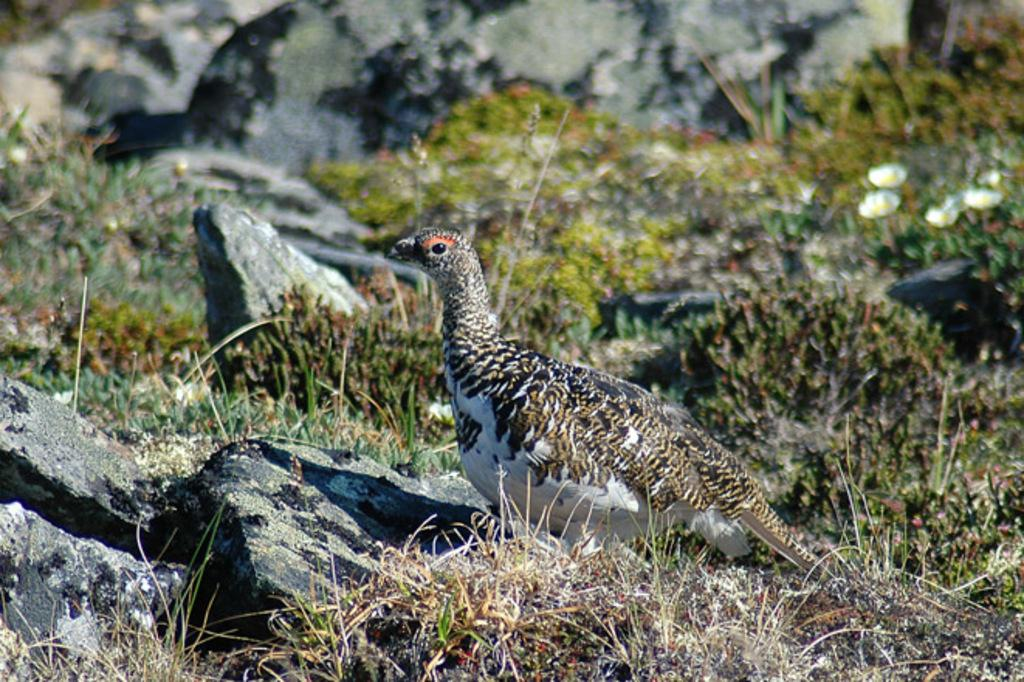What type of animal can be seen in the image? There is a bird in the image. Where is the bird located in the image? The bird is on the ground. In which direction is the bird facing? The bird is facing towards the left side. What type of vegetation is present on the ground in the image? There is grass, plants, and flowers on the ground in the image. Are there any other objects on the ground in the image? Yes, there are rocks on the ground in the image. Can you see the bird holding a sack in the image? No, there is no sack present in the image. The bird is not holding anything. 